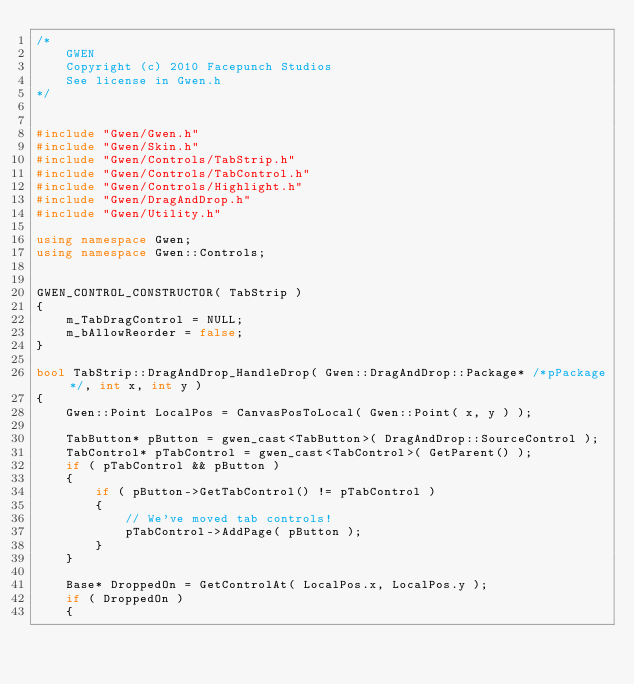Convert code to text. <code><loc_0><loc_0><loc_500><loc_500><_C++_>/*
	GWEN
	Copyright (c) 2010 Facepunch Studios
	See license in Gwen.h
*/


#include "Gwen/Gwen.h"
#include "Gwen/Skin.h"
#include "Gwen/Controls/TabStrip.h"
#include "Gwen/Controls/TabControl.h"
#include "Gwen/Controls/Highlight.h"
#include "Gwen/DragAndDrop.h"
#include "Gwen/Utility.h"

using namespace Gwen;
using namespace Gwen::Controls;


GWEN_CONTROL_CONSTRUCTOR( TabStrip )
{
	m_TabDragControl = NULL;
	m_bAllowReorder = false;
}

bool TabStrip::DragAndDrop_HandleDrop( Gwen::DragAndDrop::Package* /*pPackage*/, int x, int y )
{
	Gwen::Point LocalPos = CanvasPosToLocal( Gwen::Point( x, y ) );

	TabButton* pButton = gwen_cast<TabButton>( DragAndDrop::SourceControl );
	TabControl* pTabControl = gwen_cast<TabControl>( GetParent() );
	if ( pTabControl && pButton )
	{
		if ( pButton->GetTabControl() != pTabControl )
		{
			// We've moved tab controls!
			pTabControl->AddPage( pButton );
		}
	}

	Base* DroppedOn = GetControlAt( LocalPos.x, LocalPos.y );
	if ( DroppedOn )
	{</code> 